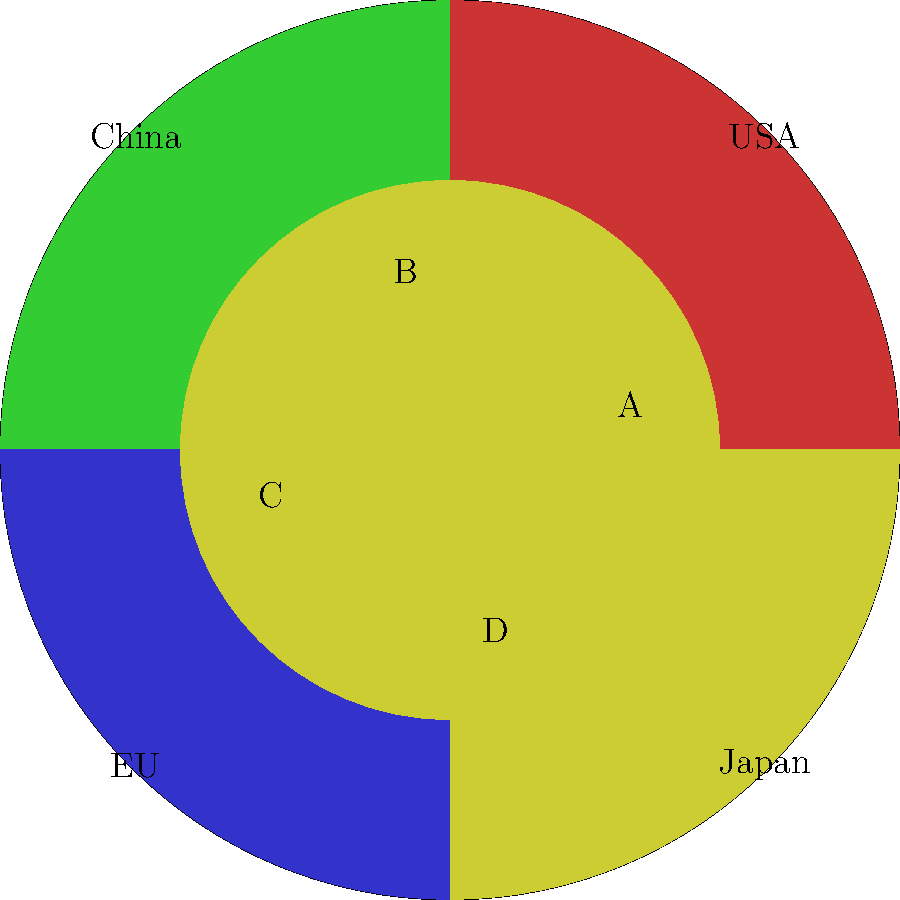A manufacturing company's global market share is represented by the pie chart above, where each quadrant represents a different country or region. The inner circle divides each country's market into two segments: A (domestic market) and B (export market). If the total global market size is $100 billion, and Japan's domestic market (segment A) accounts for $12 billion, what percentage of the company's total market share does Japan's export market (segment D) represent? Let's approach this step-by-step:

1) First, we need to determine Japan's total market share. From the pie chart, we can see that Japan occupies 1/4 of the circle, which means 25% of the total market.

2) Given that the total global market size is $100 billion, Japan's total market share is:
   $100 billion * 25% = $25 billion

3) We're told that Japan's domestic market (segment A) accounts for $12 billion. This means that Japan's export market (segment D) must account for the remainder:
   $25 billion - $12 billion = $13 billion

4) To find what percentage this represents of the company's total market share, we divide Japan's export market value by the total global market size:
   $$(13 billion) / (100 billion) * 100% = 13%$$

Therefore, Japan's export market (segment D) represents 13% of the company's total market share.
Answer: 13% 